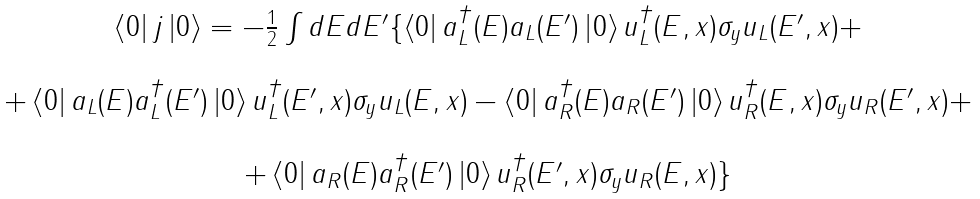Convert formula to latex. <formula><loc_0><loc_0><loc_500><loc_500>\begin{array} { c } \left \langle 0 \right | j \left | 0 \right \rangle = - \frac { 1 } { 2 } \int d E d E ^ { \prime } \{ \left \langle 0 \right | a _ { L } ^ { \dagger } ( E ) a _ { L } ( E ^ { \prime } ) \left | 0 \right \rangle u _ { L } ^ { \dagger } ( E , x ) \sigma _ { y } u _ { L } ( E ^ { \prime } , x ) + \\ \\ + \left \langle 0 \right | a _ { L } ( E ) a _ { L } ^ { \dagger } ( E ^ { \prime } ) \left | 0 \right \rangle u _ { L } ^ { \dagger } ( E ^ { \prime } , x ) \sigma _ { y } u _ { L } ( E , x ) - \left \langle 0 \right | a _ { R } ^ { \dagger } ( E ) a _ { R } ( E ^ { \prime } ) \left | 0 \right \rangle u _ { R } ^ { \dagger } ( E , x ) \sigma _ { y } u _ { R } ( E ^ { \prime } , x ) + \\ \\ + \left \langle 0 \right | a _ { R } ( E ) a _ { R } ^ { \dagger } ( E ^ { \prime } ) \left | 0 \right \rangle u _ { R } ^ { \dagger } ( E ^ { \prime } , x ) \sigma _ { y } u _ { R } ( E , x ) \} \end{array}</formula> 